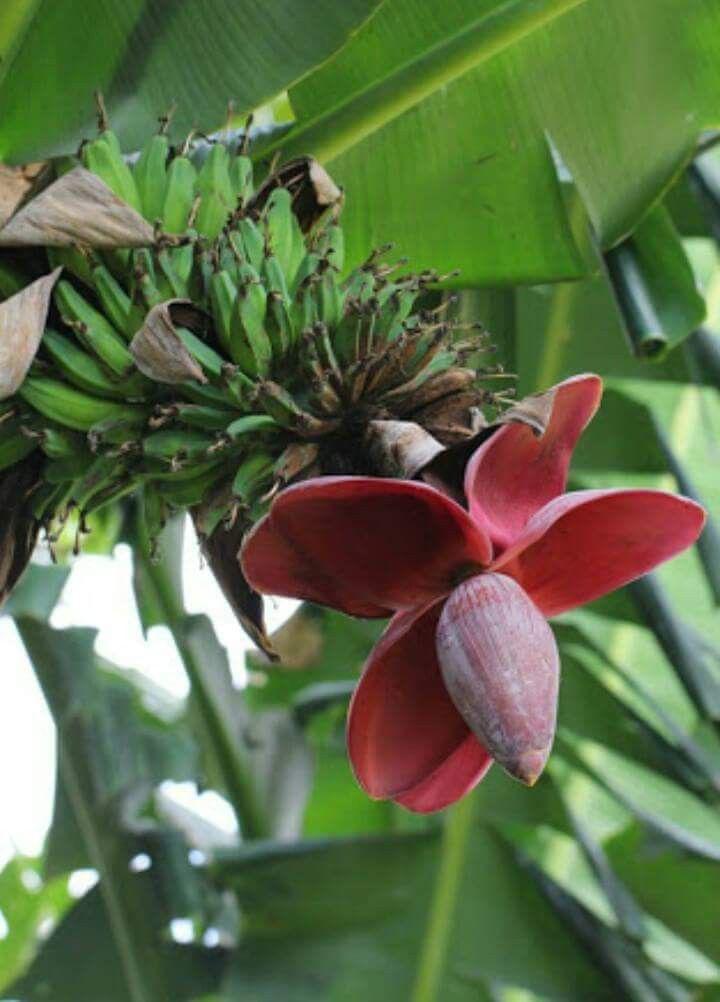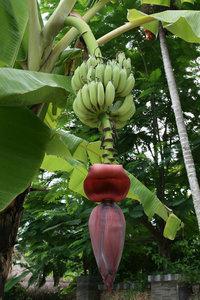The first image is the image on the left, the second image is the image on the right. Evaluate the accuracy of this statement regarding the images: "At the bottom of the bananas the flower has at least four petals open.". Is it true? Answer yes or no. Yes. The first image is the image on the left, the second image is the image on the right. Analyze the images presented: Is the assertion "There is exactly one flower petal in the left image." valid? Answer yes or no. No. 